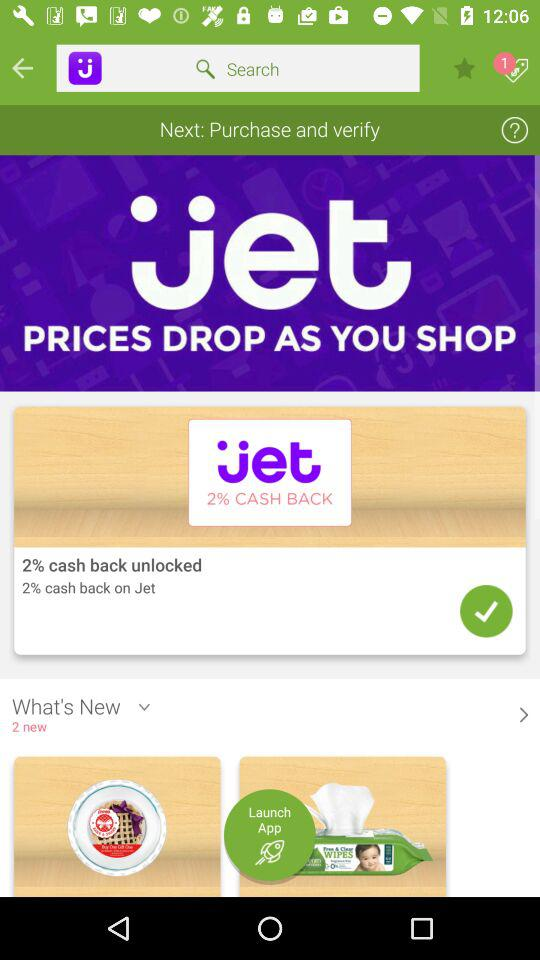How many items are in the 'What's New' section?
Answer the question using a single word or phrase. 2 